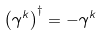<formula> <loc_0><loc_0><loc_500><loc_500>\left ( \gamma ^ { k } \right ) ^ { \dagger } = - \gamma ^ { k }</formula> 